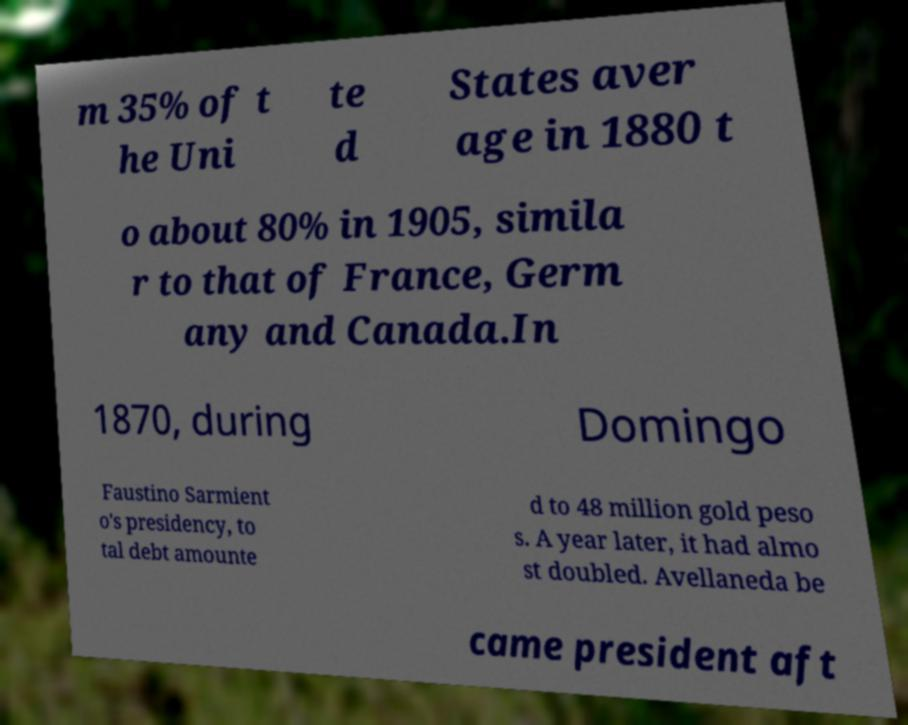Can you accurately transcribe the text from the provided image for me? m 35% of t he Uni te d States aver age in 1880 t o about 80% in 1905, simila r to that of France, Germ any and Canada.In 1870, during Domingo Faustino Sarmient o's presidency, to tal debt amounte d to 48 million gold peso s. A year later, it had almo st doubled. Avellaneda be came president aft 